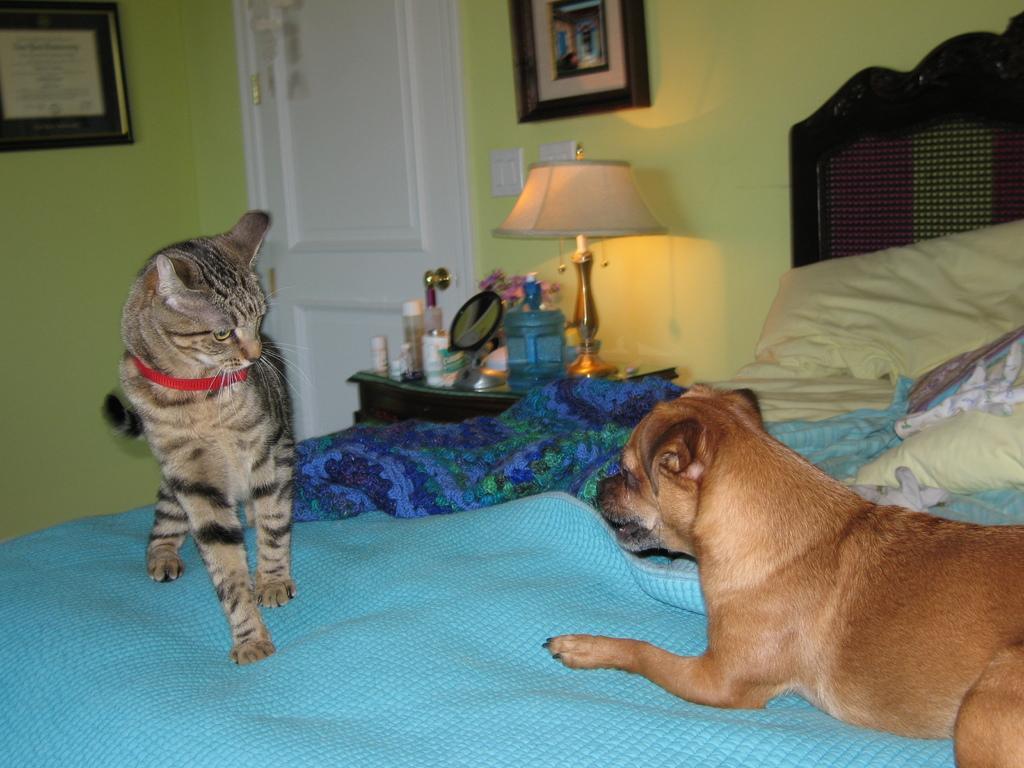Please provide a concise description of this image. In this picture we can see a dog and a cat is on the bed, besides to the bed we can find a lamp and bottles on the table and also we can see wall paintings. 